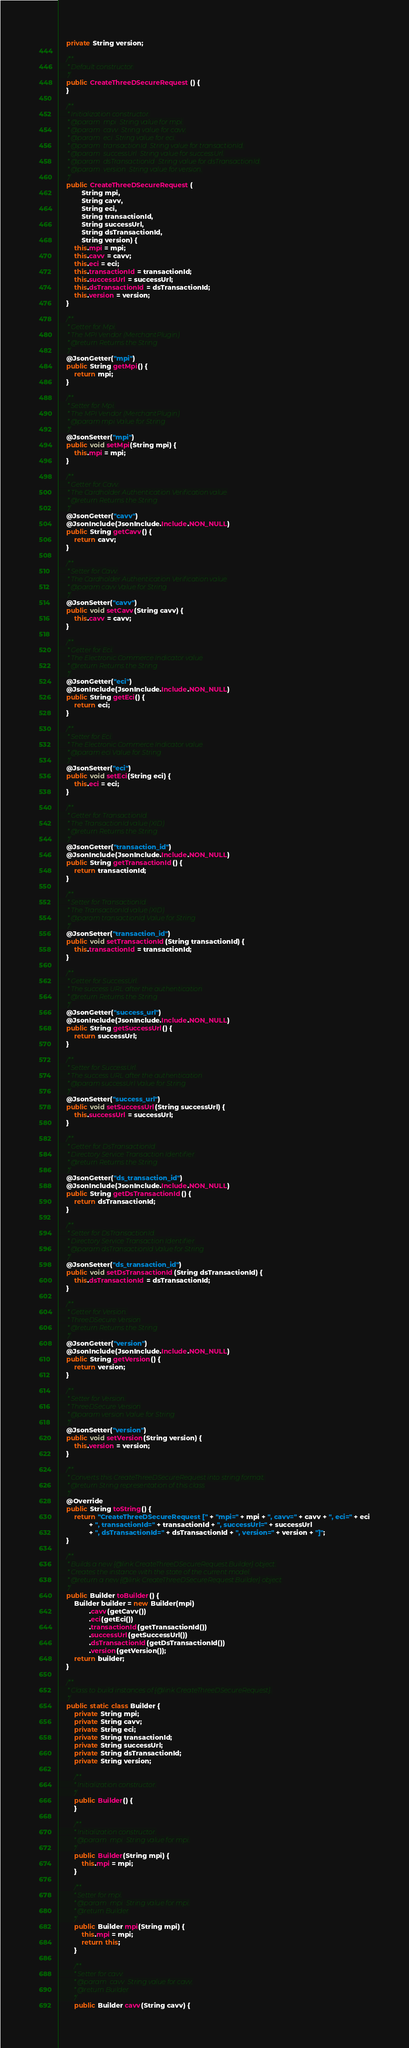<code> <loc_0><loc_0><loc_500><loc_500><_Java_>    private String version;

    /**
     * Default constructor.
     */
    public CreateThreeDSecureRequest() {
    }

    /**
     * Initialization constructor.
     * @param  mpi  String value for mpi.
     * @param  cavv  String value for cavv.
     * @param  eci  String value for eci.
     * @param  transactionId  String value for transactionId.
     * @param  successUrl  String value for successUrl.
     * @param  dsTransactionId  String value for dsTransactionId.
     * @param  version  String value for version.
     */
    public CreateThreeDSecureRequest(
            String mpi,
            String cavv,
            String eci,
            String transactionId,
            String successUrl,
            String dsTransactionId,
            String version) {
        this.mpi = mpi;
        this.cavv = cavv;
        this.eci = eci;
        this.transactionId = transactionId;
        this.successUrl = successUrl;
        this.dsTransactionId = dsTransactionId;
        this.version = version;
    }

    /**
     * Getter for Mpi.
     * The MPI Vendor (MerchantPlugin)
     * @return Returns the String
     */
    @JsonGetter("mpi")
    public String getMpi() {
        return mpi;
    }

    /**
     * Setter for Mpi.
     * The MPI Vendor (MerchantPlugin)
     * @param mpi Value for String
     */
    @JsonSetter("mpi")
    public void setMpi(String mpi) {
        this.mpi = mpi;
    }

    /**
     * Getter for Cavv.
     * The Cardholder Authentication Verification value
     * @return Returns the String
     */
    @JsonGetter("cavv")
    @JsonInclude(JsonInclude.Include.NON_NULL)
    public String getCavv() {
        return cavv;
    }

    /**
     * Setter for Cavv.
     * The Cardholder Authentication Verification value
     * @param cavv Value for String
     */
    @JsonSetter("cavv")
    public void setCavv(String cavv) {
        this.cavv = cavv;
    }

    /**
     * Getter for Eci.
     * The Electronic Commerce Indicator value
     * @return Returns the String
     */
    @JsonGetter("eci")
    @JsonInclude(JsonInclude.Include.NON_NULL)
    public String getEci() {
        return eci;
    }

    /**
     * Setter for Eci.
     * The Electronic Commerce Indicator value
     * @param eci Value for String
     */
    @JsonSetter("eci")
    public void setEci(String eci) {
        this.eci = eci;
    }

    /**
     * Getter for TransactionId.
     * The TransactionId value (XID)
     * @return Returns the String
     */
    @JsonGetter("transaction_id")
    @JsonInclude(JsonInclude.Include.NON_NULL)
    public String getTransactionId() {
        return transactionId;
    }

    /**
     * Setter for TransactionId.
     * The TransactionId value (XID)
     * @param transactionId Value for String
     */
    @JsonSetter("transaction_id")
    public void setTransactionId(String transactionId) {
        this.transactionId = transactionId;
    }

    /**
     * Getter for SuccessUrl.
     * The success URL after the authentication
     * @return Returns the String
     */
    @JsonGetter("success_url")
    @JsonInclude(JsonInclude.Include.NON_NULL)
    public String getSuccessUrl() {
        return successUrl;
    }

    /**
     * Setter for SuccessUrl.
     * The success URL after the authentication
     * @param successUrl Value for String
     */
    @JsonSetter("success_url")
    public void setSuccessUrl(String successUrl) {
        this.successUrl = successUrl;
    }

    /**
     * Getter for DsTransactionId.
     * Directory Service Transaction Identifier
     * @return Returns the String
     */
    @JsonGetter("ds_transaction_id")
    @JsonInclude(JsonInclude.Include.NON_NULL)
    public String getDsTransactionId() {
        return dsTransactionId;
    }

    /**
     * Setter for DsTransactionId.
     * Directory Service Transaction Identifier
     * @param dsTransactionId Value for String
     */
    @JsonSetter("ds_transaction_id")
    public void setDsTransactionId(String dsTransactionId) {
        this.dsTransactionId = dsTransactionId;
    }

    /**
     * Getter for Version.
     * ThreeDSecure Version
     * @return Returns the String
     */
    @JsonGetter("version")
    @JsonInclude(JsonInclude.Include.NON_NULL)
    public String getVersion() {
        return version;
    }

    /**
     * Setter for Version.
     * ThreeDSecure Version
     * @param version Value for String
     */
    @JsonSetter("version")
    public void setVersion(String version) {
        this.version = version;
    }

    /**
     * Converts this CreateThreeDSecureRequest into string format.
     * @return String representation of this class
     */
    @Override
    public String toString() {
        return "CreateThreeDSecureRequest [" + "mpi=" + mpi + ", cavv=" + cavv + ", eci=" + eci
                + ", transactionId=" + transactionId + ", successUrl=" + successUrl
                + ", dsTransactionId=" + dsTransactionId + ", version=" + version + "]";
    }

    /**
     * Builds a new {@link CreateThreeDSecureRequest.Builder} object.
     * Creates the instance with the state of the current model.
     * @return a new {@link CreateThreeDSecureRequest.Builder} object
     */
    public Builder toBuilder() {
        Builder builder = new Builder(mpi)
                .cavv(getCavv())
                .eci(getEci())
                .transactionId(getTransactionId())
                .successUrl(getSuccessUrl())
                .dsTransactionId(getDsTransactionId())
                .version(getVersion());
        return builder;
    }

    /**
     * Class to build instances of {@link CreateThreeDSecureRequest}.
     */
    public static class Builder {
        private String mpi;
        private String cavv;
        private String eci;
        private String transactionId;
        private String successUrl;
        private String dsTransactionId;
        private String version;

        /**
         * Initialization constructor.
         */
        public Builder() {
        }

        /**
         * Initialization constructor.
         * @param  mpi  String value for mpi.
         */
        public Builder(String mpi) {
            this.mpi = mpi;
        }

        /**
         * Setter for mpi.
         * @param  mpi  String value for mpi.
         * @return Builder
         */
        public Builder mpi(String mpi) {
            this.mpi = mpi;
            return this;
        }

        /**
         * Setter for cavv.
         * @param  cavv  String value for cavv.
         * @return Builder
         */
        public Builder cavv(String cavv) {</code> 